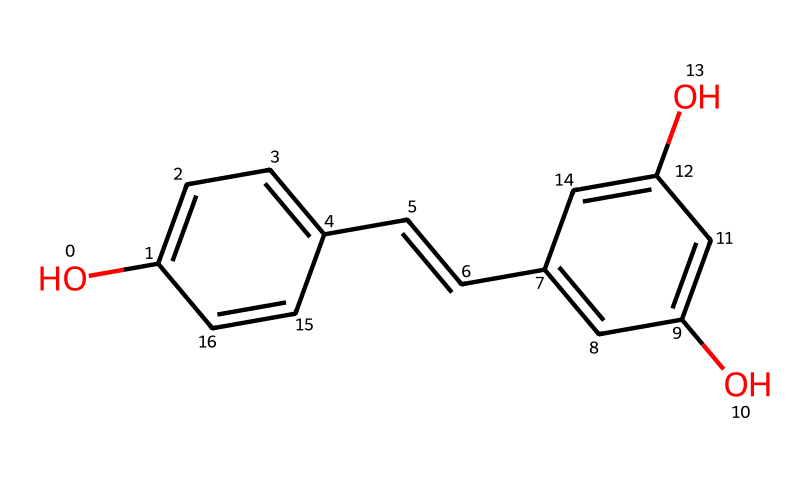What is the molecular formula of resveratrol? To find the molecular formula from the SMILES representation, we identify the types and number of atoms present. Counting the carbon (C), hydrogen (H), and oxygen (O) atoms gives us C14H12O3.
Answer: C14H12O3 How many hydroxyl (–OH) groups are present in resveratrol? The SMILES representation shows two hydroxyl (–OH) groups indicated by the 'O' connected to carbons.
Answer: 3 What type of structural feature indicates that resveratrol is a stilbene? The presence of the double bond between two carbon atoms (noted by /C=C/) indicates that it belongs to the stilbene class of compounds.
Answer: double bond What type of antioxidant property does resveratrol possess? Resveratrol is known for its ability to scavenge free radicals, which is a common property of many antioxidants. This effectively reduces oxidative stress in the body.
Answer: scavenger How do the phenolic rings in resveratrol contribute to its antioxidant activity? The phenolic rings contain hydroxyl groups that can donate hydrogen atoms to free radicals, thus stabilizing them and preventing oxidative damage, which is essential for its effectiveness as an antioxidant.
Answer: stabilization What does the presence of multiple aromatic rings signify in resveratrol's structure? The presence of multiple aromatic rings suggests a higher stability due to resonance, which contributes to the compound's pharmacological activity and antioxidant properties.
Answer: stability 